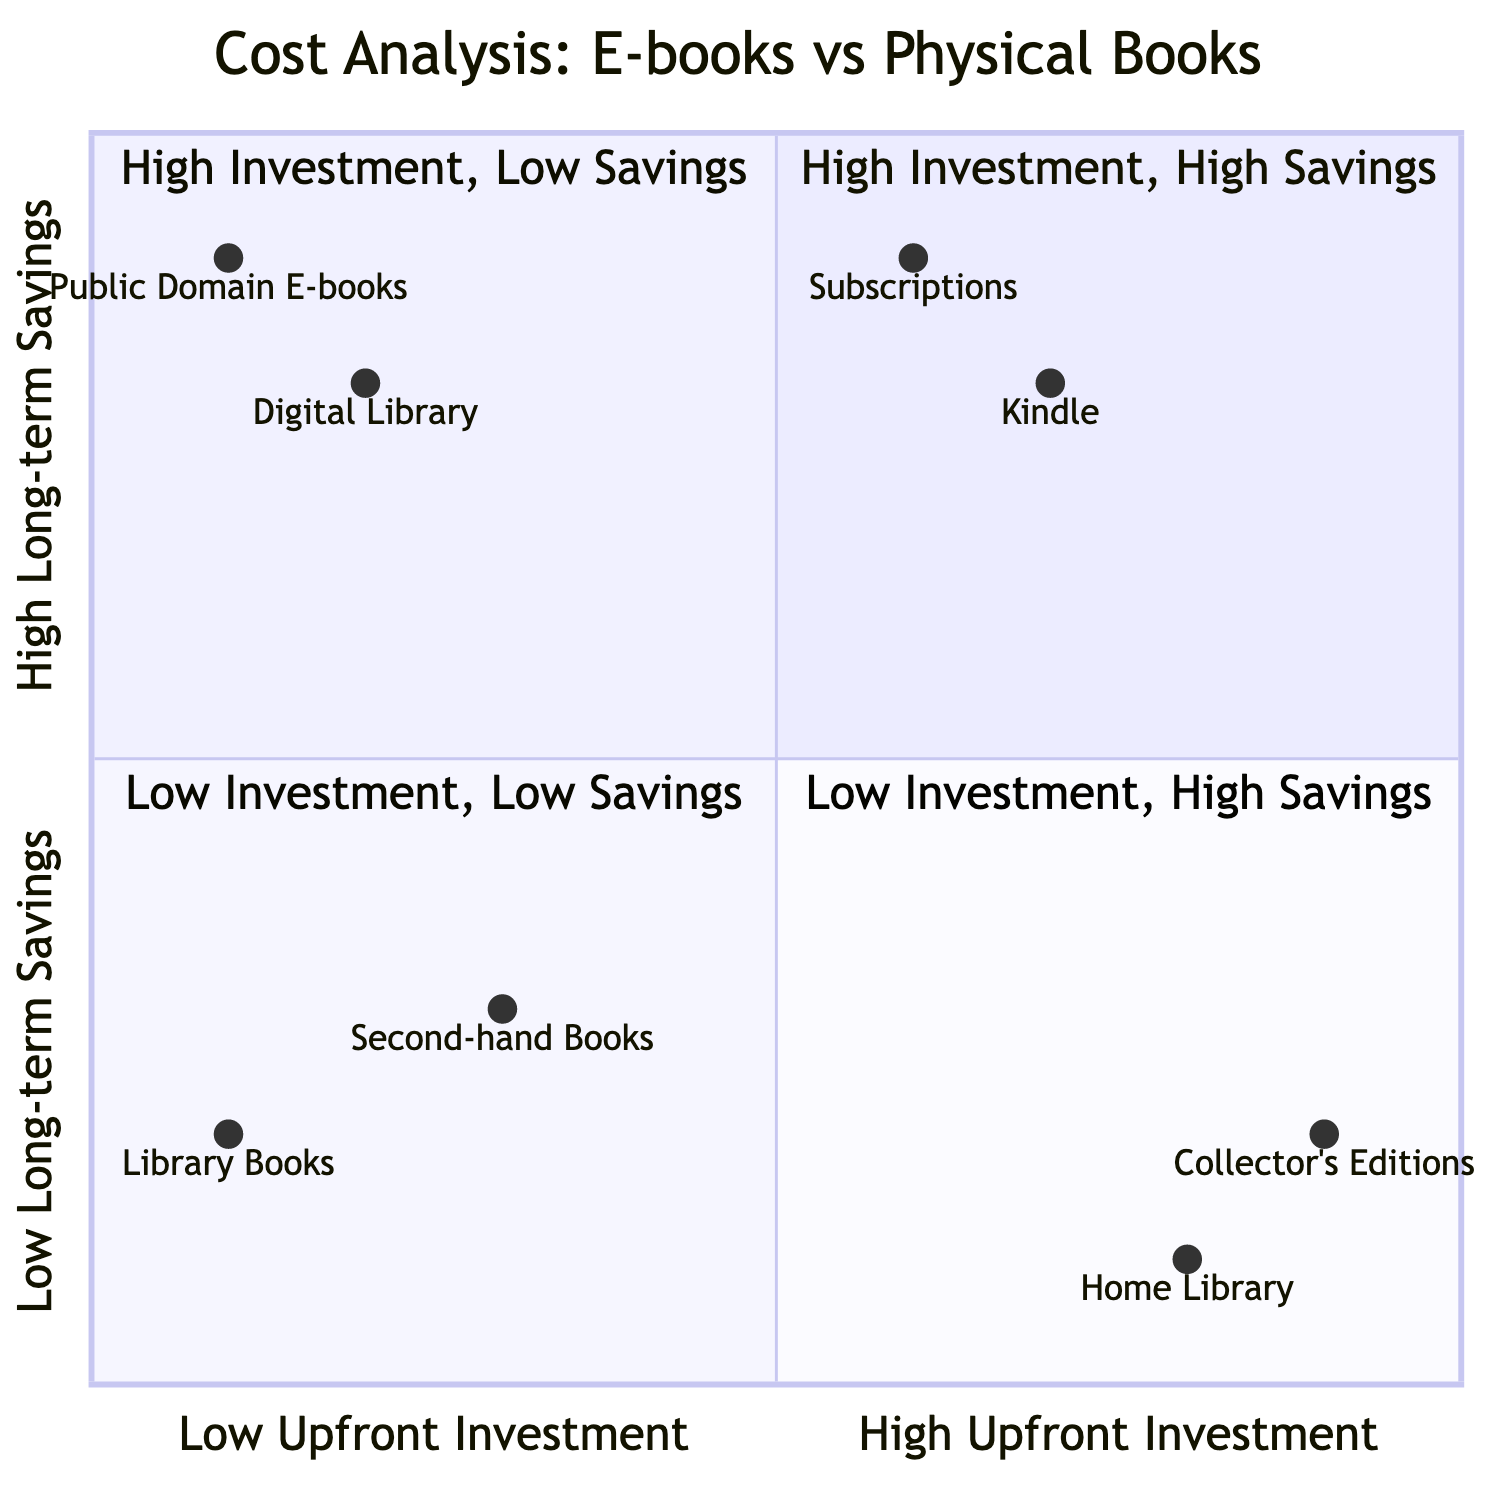What quadrant does the Kindle device fall into? The Kindle device is located in the quadrant labeled "High Investment, High Savings" based on its coordinates [0.7, 0.8].
Answer: High Investment, High Savings How many elements are in the "Low Investment, Low Savings" quadrant? The "Low Investment, Low Savings" quadrant contains two elements: "Second-hand Physical Books" and "Library Books".
Answer: 2 What is the long-term savings value of the Subscription Services? The long-term savings value for Subscription Services is represented by the y-coordinate in the quadrant, which is 0.9.
Answer: 0.9 Which element has the highest upfront investment among the listed options? "Collector's Editions" has the highest upfront investment with an x-coordinate of 0.9, indicating a high initial cost.
Answer: Collector's Editions What element represents the lowest upfront investment? "Public Domain E-books" represents the lowest upfront investment with an x-coordinate of 0.1, indicating a minimal cost to acquire.
Answer: Public Domain E-books Which element is closest to the "High Investment, Low Savings" quadrant? The element titled "Home Library Setup," with coordinates [0.8, 0.1], is closest to the "High Investment, Low Savings" quadrant.
Answer: Home Library Setup In which quadrant do "Public Domain E-books" and "Digital Library Access" fall? Both "Public Domain E-books" and "Digital Library Access" fall into the "Low Investment, High Savings" quadrant, indicated by their coordinates.
Answer: Low Investment, High Savings How does the upfront investment of Digital Library Access compare to Second-hand Physical Books? Digital Library Access has a lower upfront investment (x=0.2) compared to Second-hand Physical Books (x=0.3), indicating it is more cost-effective initially.
Answer: Lower Which of the elements has the highest long-term savings value? The element "Kindle Device Purchase" has the highest long-term savings value of 0.9 in the upper quadrant.
Answer: Kindle Device Purchase 